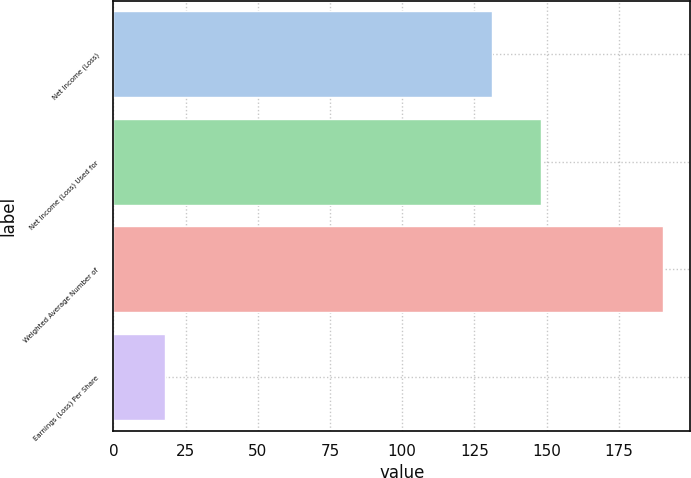Convert chart to OTSL. <chart><loc_0><loc_0><loc_500><loc_500><bar_chart><fcel>Net Income (Loss)<fcel>Net Income (Loss) Used for<fcel>Weighted Average Number of<fcel>Earnings (Loss) Per Share<nl><fcel>131<fcel>148.22<fcel>190.22<fcel>17.98<nl></chart> 